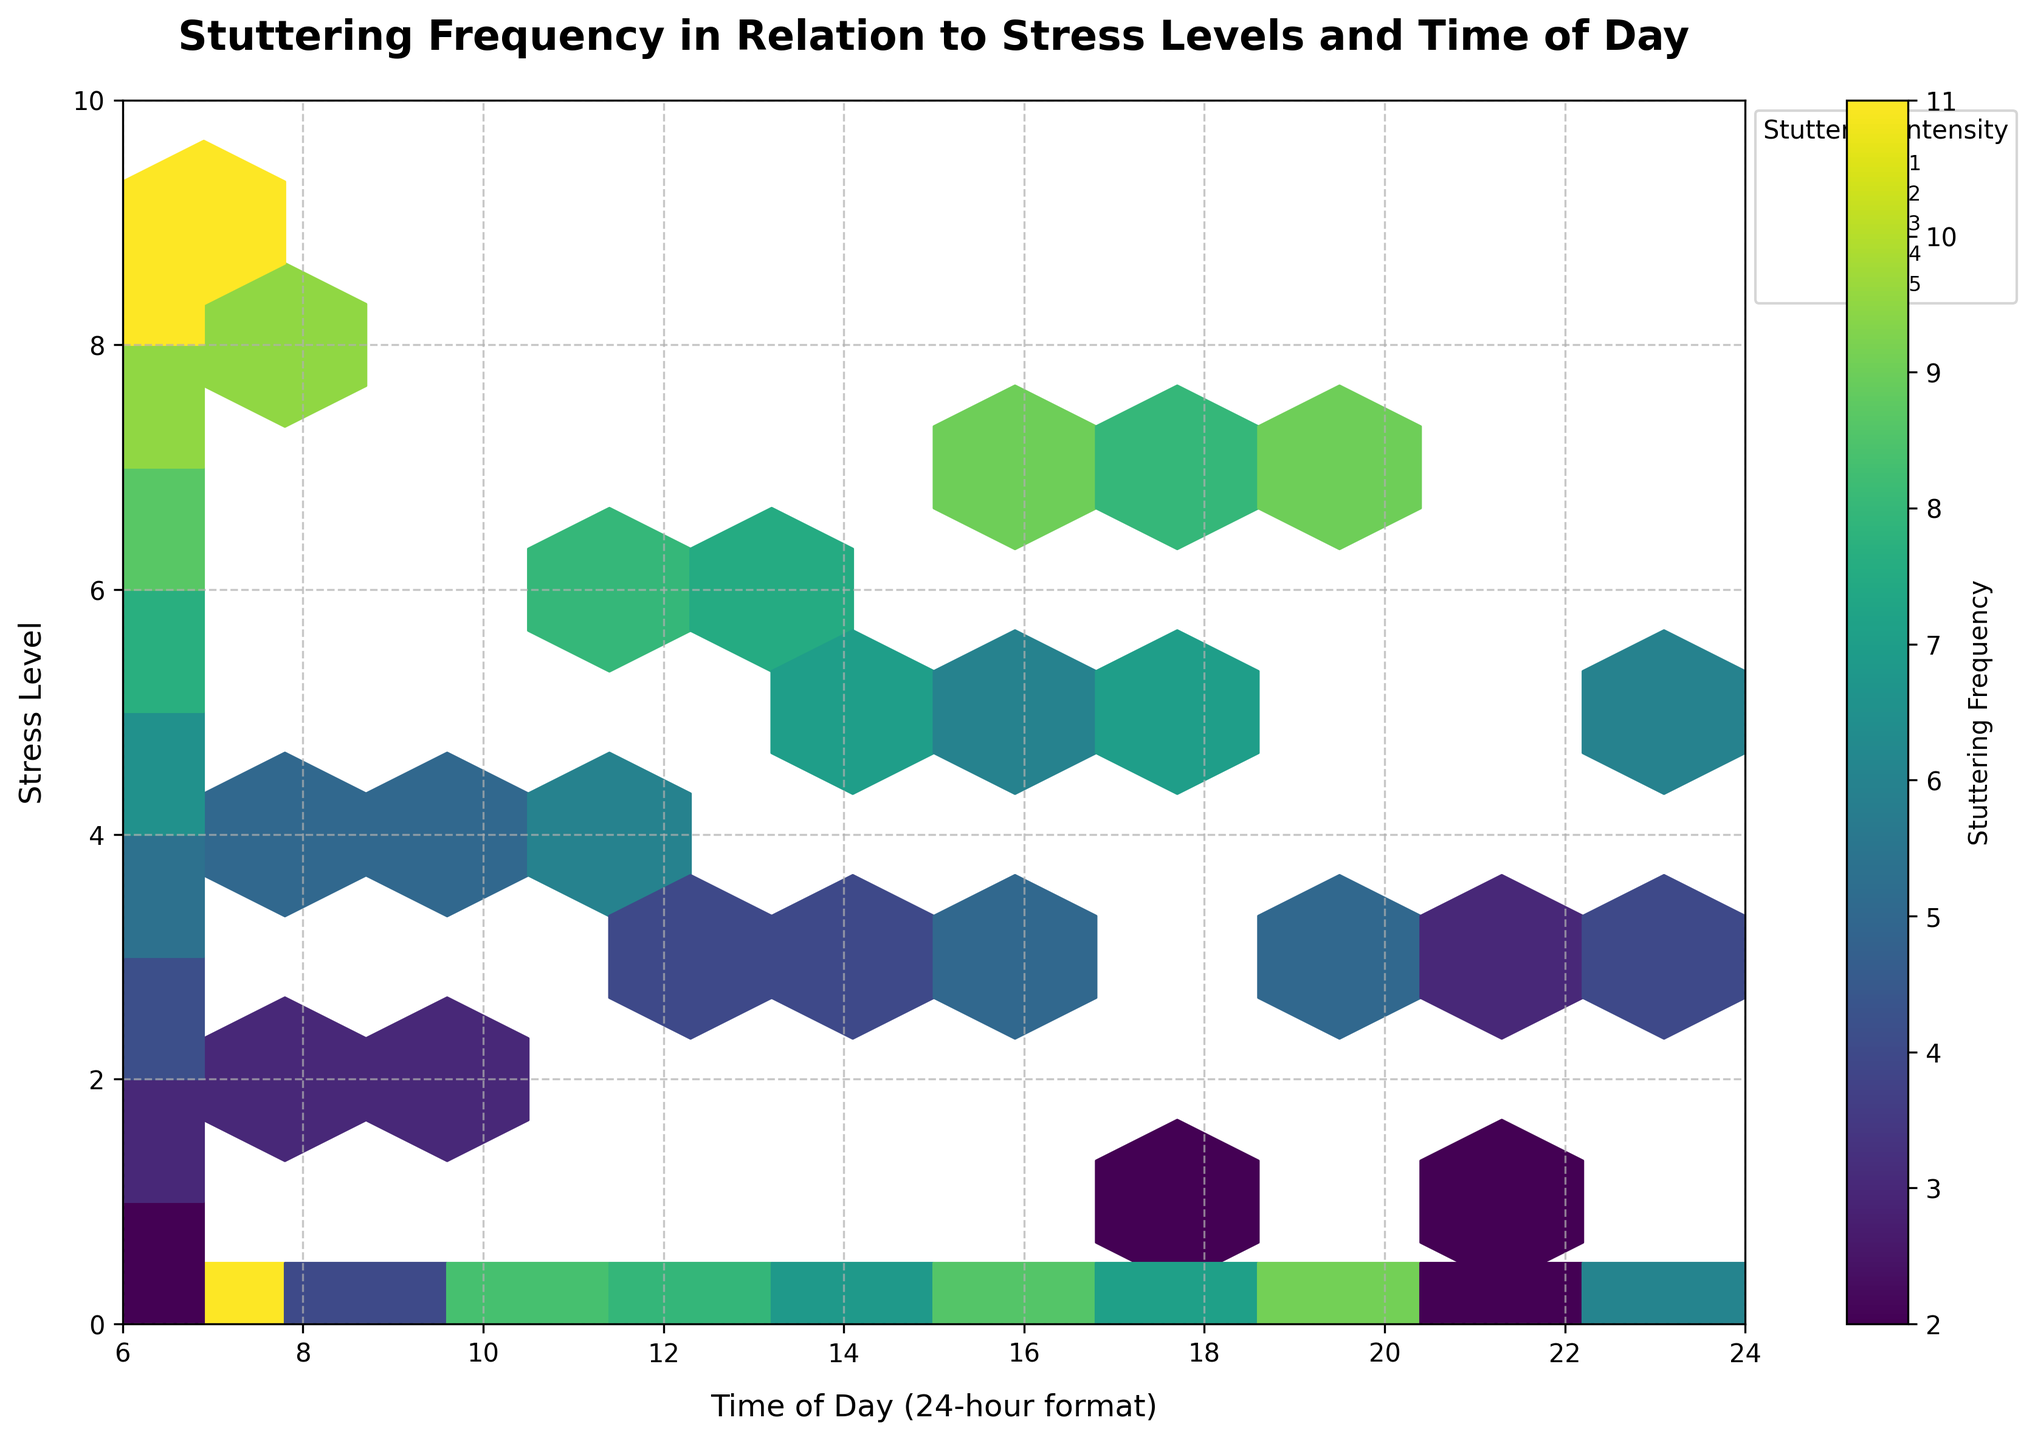What is the title of the hexbin plot? The title of the plot is written at the top center of the figure inside the title box.
Answer: Stuttering Frequency in Relation to Stress Levels and Time of Day What do the x and y axes represent in this plot? The x-axis label is at the bottom and the y-axis label is on the left side of the figure.
Answer: Time of Day (24-hour format) and Stress Level What does the color gradient signify in the plot? The colorbar next to the plot shows the gradient of colors, indicating the variable it represents.
Answer: Stuttering Frequency At what time of day and stress level is the stuttering frequency the highest? By observing the darkest hexagons, one can determine where the highest frequency is located. It is at the intersection of the levels shown in the color gradient.
Answer: 6:00 and stress level 9 How does stuttering frequency change with increasing stress levels? To assess this, compare hexagons of different colors along the y-axis while keeping the x-axis values similar. More intense colors at higher stress levels indicate increased stuttering frequency.
Answer: It increases In which time range do the higher stress levels predominantly appear? Observing the distribution of darker hexagons along the x-axis will show the time range where higher stress levels are more common.
Answer: From 16:00 to 20:00 Are there more stuttering episodes (frequency) during the morning or evening? Compare the color intensity and density of hexagons representing stuttering frequency in the morning (6:00 to 12:00) vs. the evening (18:00 to 24:00). The side with more darker colors will have more episodes.
Answer: Evening What is the most frequent stuttering intensity level, and how can you tell? The legend on the plot shows different sizes of scatter symbols, indicating stuttering intensity levels. The most frequently appearing size indicates the common intensity.
Answer: 2 Do high stuttering frequencies correlate with high stress levels? To determine this, observe if darker hexagons (high frequencies) are mostly in the upper part of the y-axis (high stress levels).
Answer: Yes How does the time of day affect stuttering intensity? To assess this, observe the sizes of scatter symbols along the time of day axes. Larger symbols indicate higher intensity levels. If larger symbols are concentrated at certain times, those times affect intensity more.
Answer: Intensity is higher in the evening 